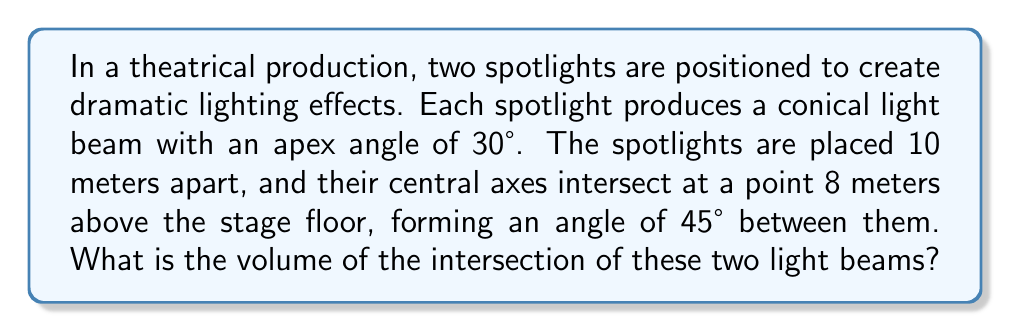Can you answer this question? Let's approach this step-by-step:

1) First, we need to visualize the problem. The intersection of two cones forms a shape called a bicone.

2) The volume of a bicone is given by the formula:

   $$V = \frac{2\pi h^3}{3} \cdot \frac{\tan^2 \alpha}{\tan^2 \beta}$$

   Where:
   $h$ is the height of the bicone
   $\alpha$ is half of the apex angle of each cone
   $\beta$ is half of the angle between the central axes of the cones

3) We're given that the apex angle is 30°, so $\alpha = 15°$
   The angle between the central axes is 45°, so $\beta = 22.5°$

4) To find $h$, we need to use trigonometry:

   $$\tan 22.5° = \frac{5}{h}$$
   $$h = \frac{5}{\tan 22.5°} \approx 12.07 \text{ meters}$$

5) Now we can substitute these values into our volume formula:

   $$V = \frac{2\pi (12.07)^3}{3} \cdot \frac{\tan^2 15°}{\tan^2 22.5°}$$

6) Calculating this:

   $$V \approx 2788.37 \text{ cubic meters}$$

7) Rounding to the nearest whole number:

   $$V \approx 2788 \text{ cubic meters}$$
Answer: 2788 cubic meters 